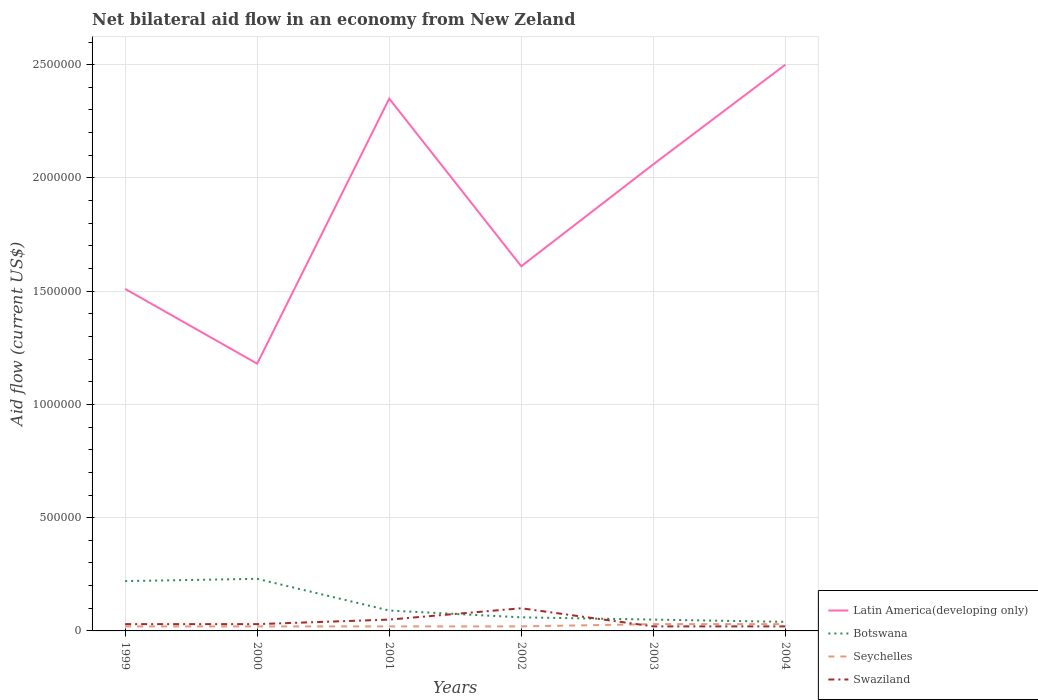Is the number of lines equal to the number of legend labels?
Offer a terse response. Yes. Across all years, what is the maximum net bilateral aid flow in Latin America(developing only)?
Ensure brevity in your answer.  1.18e+06. What is the difference between the highest and the second highest net bilateral aid flow in Botswana?
Give a very brief answer. 1.90e+05. What is the difference between the highest and the lowest net bilateral aid flow in Botswana?
Give a very brief answer. 2. How many lines are there?
Offer a terse response. 4. How many years are there in the graph?
Offer a terse response. 6. Are the values on the major ticks of Y-axis written in scientific E-notation?
Make the answer very short. No. Does the graph contain any zero values?
Give a very brief answer. No. Does the graph contain grids?
Your answer should be very brief. Yes. Where does the legend appear in the graph?
Provide a short and direct response. Bottom right. How are the legend labels stacked?
Give a very brief answer. Vertical. What is the title of the graph?
Offer a very short reply. Net bilateral aid flow in an economy from New Zeland. Does "Malaysia" appear as one of the legend labels in the graph?
Your answer should be very brief. No. What is the label or title of the Y-axis?
Keep it short and to the point. Aid flow (current US$). What is the Aid flow (current US$) of Latin America(developing only) in 1999?
Keep it short and to the point. 1.51e+06. What is the Aid flow (current US$) of Botswana in 1999?
Provide a short and direct response. 2.20e+05. What is the Aid flow (current US$) in Seychelles in 1999?
Your response must be concise. 2.00e+04. What is the Aid flow (current US$) of Swaziland in 1999?
Your answer should be compact. 3.00e+04. What is the Aid flow (current US$) of Latin America(developing only) in 2000?
Give a very brief answer. 1.18e+06. What is the Aid flow (current US$) in Latin America(developing only) in 2001?
Offer a very short reply. 2.35e+06. What is the Aid flow (current US$) in Botswana in 2001?
Ensure brevity in your answer.  9.00e+04. What is the Aid flow (current US$) in Seychelles in 2001?
Keep it short and to the point. 2.00e+04. What is the Aid flow (current US$) of Latin America(developing only) in 2002?
Your response must be concise. 1.61e+06. What is the Aid flow (current US$) of Latin America(developing only) in 2003?
Your response must be concise. 2.06e+06. What is the Aid flow (current US$) of Seychelles in 2003?
Ensure brevity in your answer.  3.00e+04. What is the Aid flow (current US$) of Swaziland in 2003?
Your response must be concise. 2.00e+04. What is the Aid flow (current US$) in Latin America(developing only) in 2004?
Keep it short and to the point. 2.50e+06. What is the Aid flow (current US$) in Botswana in 2004?
Offer a terse response. 4.00e+04. What is the Aid flow (current US$) in Seychelles in 2004?
Offer a very short reply. 3.00e+04. Across all years, what is the maximum Aid flow (current US$) in Latin America(developing only)?
Provide a succinct answer. 2.50e+06. Across all years, what is the minimum Aid flow (current US$) of Latin America(developing only)?
Keep it short and to the point. 1.18e+06. What is the total Aid flow (current US$) in Latin America(developing only) in the graph?
Provide a short and direct response. 1.12e+07. What is the total Aid flow (current US$) in Botswana in the graph?
Your answer should be compact. 6.90e+05. What is the difference between the Aid flow (current US$) of Latin America(developing only) in 1999 and that in 2000?
Provide a short and direct response. 3.30e+05. What is the difference between the Aid flow (current US$) in Botswana in 1999 and that in 2000?
Your response must be concise. -10000. What is the difference between the Aid flow (current US$) in Seychelles in 1999 and that in 2000?
Provide a succinct answer. 0. What is the difference between the Aid flow (current US$) of Swaziland in 1999 and that in 2000?
Your answer should be compact. 0. What is the difference between the Aid flow (current US$) in Latin America(developing only) in 1999 and that in 2001?
Provide a short and direct response. -8.40e+05. What is the difference between the Aid flow (current US$) in Botswana in 1999 and that in 2001?
Give a very brief answer. 1.30e+05. What is the difference between the Aid flow (current US$) of Seychelles in 1999 and that in 2001?
Offer a very short reply. 0. What is the difference between the Aid flow (current US$) in Swaziland in 1999 and that in 2001?
Give a very brief answer. -2.00e+04. What is the difference between the Aid flow (current US$) of Latin America(developing only) in 1999 and that in 2002?
Your response must be concise. -1.00e+05. What is the difference between the Aid flow (current US$) in Botswana in 1999 and that in 2002?
Offer a very short reply. 1.60e+05. What is the difference between the Aid flow (current US$) in Swaziland in 1999 and that in 2002?
Ensure brevity in your answer.  -7.00e+04. What is the difference between the Aid flow (current US$) in Latin America(developing only) in 1999 and that in 2003?
Your response must be concise. -5.50e+05. What is the difference between the Aid flow (current US$) in Botswana in 1999 and that in 2003?
Ensure brevity in your answer.  1.70e+05. What is the difference between the Aid flow (current US$) of Seychelles in 1999 and that in 2003?
Your response must be concise. -10000. What is the difference between the Aid flow (current US$) in Swaziland in 1999 and that in 2003?
Provide a short and direct response. 10000. What is the difference between the Aid flow (current US$) of Latin America(developing only) in 1999 and that in 2004?
Make the answer very short. -9.90e+05. What is the difference between the Aid flow (current US$) of Botswana in 1999 and that in 2004?
Offer a terse response. 1.80e+05. What is the difference between the Aid flow (current US$) of Seychelles in 1999 and that in 2004?
Your response must be concise. -10000. What is the difference between the Aid flow (current US$) of Latin America(developing only) in 2000 and that in 2001?
Your answer should be compact. -1.17e+06. What is the difference between the Aid flow (current US$) of Seychelles in 2000 and that in 2001?
Your answer should be compact. 0. What is the difference between the Aid flow (current US$) in Latin America(developing only) in 2000 and that in 2002?
Make the answer very short. -4.30e+05. What is the difference between the Aid flow (current US$) of Botswana in 2000 and that in 2002?
Offer a very short reply. 1.70e+05. What is the difference between the Aid flow (current US$) in Seychelles in 2000 and that in 2002?
Keep it short and to the point. 0. What is the difference between the Aid flow (current US$) in Swaziland in 2000 and that in 2002?
Make the answer very short. -7.00e+04. What is the difference between the Aid flow (current US$) of Latin America(developing only) in 2000 and that in 2003?
Your answer should be compact. -8.80e+05. What is the difference between the Aid flow (current US$) of Botswana in 2000 and that in 2003?
Your answer should be very brief. 1.80e+05. What is the difference between the Aid flow (current US$) in Seychelles in 2000 and that in 2003?
Give a very brief answer. -10000. What is the difference between the Aid flow (current US$) in Swaziland in 2000 and that in 2003?
Keep it short and to the point. 10000. What is the difference between the Aid flow (current US$) of Latin America(developing only) in 2000 and that in 2004?
Provide a short and direct response. -1.32e+06. What is the difference between the Aid flow (current US$) in Botswana in 2000 and that in 2004?
Offer a very short reply. 1.90e+05. What is the difference between the Aid flow (current US$) in Seychelles in 2000 and that in 2004?
Your response must be concise. -10000. What is the difference between the Aid flow (current US$) in Swaziland in 2000 and that in 2004?
Your answer should be very brief. 10000. What is the difference between the Aid flow (current US$) of Latin America(developing only) in 2001 and that in 2002?
Provide a succinct answer. 7.40e+05. What is the difference between the Aid flow (current US$) of Swaziland in 2001 and that in 2002?
Your answer should be very brief. -5.00e+04. What is the difference between the Aid flow (current US$) in Latin America(developing only) in 2001 and that in 2003?
Offer a very short reply. 2.90e+05. What is the difference between the Aid flow (current US$) of Botswana in 2001 and that in 2003?
Offer a very short reply. 4.00e+04. What is the difference between the Aid flow (current US$) in Swaziland in 2001 and that in 2003?
Provide a short and direct response. 3.00e+04. What is the difference between the Aid flow (current US$) in Botswana in 2001 and that in 2004?
Your response must be concise. 5.00e+04. What is the difference between the Aid flow (current US$) of Seychelles in 2001 and that in 2004?
Offer a terse response. -10000. What is the difference between the Aid flow (current US$) in Swaziland in 2001 and that in 2004?
Your answer should be compact. 3.00e+04. What is the difference between the Aid flow (current US$) in Latin America(developing only) in 2002 and that in 2003?
Your answer should be compact. -4.50e+05. What is the difference between the Aid flow (current US$) of Latin America(developing only) in 2002 and that in 2004?
Offer a terse response. -8.90e+05. What is the difference between the Aid flow (current US$) of Latin America(developing only) in 2003 and that in 2004?
Offer a very short reply. -4.40e+05. What is the difference between the Aid flow (current US$) in Seychelles in 2003 and that in 2004?
Offer a terse response. 0. What is the difference between the Aid flow (current US$) in Swaziland in 2003 and that in 2004?
Your answer should be compact. 0. What is the difference between the Aid flow (current US$) in Latin America(developing only) in 1999 and the Aid flow (current US$) in Botswana in 2000?
Make the answer very short. 1.28e+06. What is the difference between the Aid flow (current US$) of Latin America(developing only) in 1999 and the Aid flow (current US$) of Seychelles in 2000?
Your response must be concise. 1.49e+06. What is the difference between the Aid flow (current US$) in Latin America(developing only) in 1999 and the Aid flow (current US$) in Swaziland in 2000?
Keep it short and to the point. 1.48e+06. What is the difference between the Aid flow (current US$) in Botswana in 1999 and the Aid flow (current US$) in Seychelles in 2000?
Your answer should be compact. 2.00e+05. What is the difference between the Aid flow (current US$) of Seychelles in 1999 and the Aid flow (current US$) of Swaziland in 2000?
Offer a terse response. -10000. What is the difference between the Aid flow (current US$) of Latin America(developing only) in 1999 and the Aid flow (current US$) of Botswana in 2001?
Provide a short and direct response. 1.42e+06. What is the difference between the Aid flow (current US$) of Latin America(developing only) in 1999 and the Aid flow (current US$) of Seychelles in 2001?
Offer a very short reply. 1.49e+06. What is the difference between the Aid flow (current US$) in Latin America(developing only) in 1999 and the Aid flow (current US$) in Swaziland in 2001?
Give a very brief answer. 1.46e+06. What is the difference between the Aid flow (current US$) in Botswana in 1999 and the Aid flow (current US$) in Seychelles in 2001?
Provide a short and direct response. 2.00e+05. What is the difference between the Aid flow (current US$) in Botswana in 1999 and the Aid flow (current US$) in Swaziland in 2001?
Keep it short and to the point. 1.70e+05. What is the difference between the Aid flow (current US$) of Latin America(developing only) in 1999 and the Aid flow (current US$) of Botswana in 2002?
Provide a short and direct response. 1.45e+06. What is the difference between the Aid flow (current US$) of Latin America(developing only) in 1999 and the Aid flow (current US$) of Seychelles in 2002?
Offer a very short reply. 1.49e+06. What is the difference between the Aid flow (current US$) in Latin America(developing only) in 1999 and the Aid flow (current US$) in Swaziland in 2002?
Provide a short and direct response. 1.41e+06. What is the difference between the Aid flow (current US$) in Botswana in 1999 and the Aid flow (current US$) in Seychelles in 2002?
Your answer should be compact. 2.00e+05. What is the difference between the Aid flow (current US$) of Seychelles in 1999 and the Aid flow (current US$) of Swaziland in 2002?
Your response must be concise. -8.00e+04. What is the difference between the Aid flow (current US$) of Latin America(developing only) in 1999 and the Aid flow (current US$) of Botswana in 2003?
Your answer should be very brief. 1.46e+06. What is the difference between the Aid flow (current US$) of Latin America(developing only) in 1999 and the Aid flow (current US$) of Seychelles in 2003?
Give a very brief answer. 1.48e+06. What is the difference between the Aid flow (current US$) in Latin America(developing only) in 1999 and the Aid flow (current US$) in Swaziland in 2003?
Give a very brief answer. 1.49e+06. What is the difference between the Aid flow (current US$) of Botswana in 1999 and the Aid flow (current US$) of Seychelles in 2003?
Give a very brief answer. 1.90e+05. What is the difference between the Aid flow (current US$) in Latin America(developing only) in 1999 and the Aid flow (current US$) in Botswana in 2004?
Ensure brevity in your answer.  1.47e+06. What is the difference between the Aid flow (current US$) in Latin America(developing only) in 1999 and the Aid flow (current US$) in Seychelles in 2004?
Ensure brevity in your answer.  1.48e+06. What is the difference between the Aid flow (current US$) of Latin America(developing only) in 1999 and the Aid flow (current US$) of Swaziland in 2004?
Make the answer very short. 1.49e+06. What is the difference between the Aid flow (current US$) in Botswana in 1999 and the Aid flow (current US$) in Swaziland in 2004?
Your answer should be compact. 2.00e+05. What is the difference between the Aid flow (current US$) of Latin America(developing only) in 2000 and the Aid flow (current US$) of Botswana in 2001?
Your answer should be compact. 1.09e+06. What is the difference between the Aid flow (current US$) of Latin America(developing only) in 2000 and the Aid flow (current US$) of Seychelles in 2001?
Ensure brevity in your answer.  1.16e+06. What is the difference between the Aid flow (current US$) in Latin America(developing only) in 2000 and the Aid flow (current US$) in Swaziland in 2001?
Ensure brevity in your answer.  1.13e+06. What is the difference between the Aid flow (current US$) in Botswana in 2000 and the Aid flow (current US$) in Seychelles in 2001?
Offer a terse response. 2.10e+05. What is the difference between the Aid flow (current US$) in Botswana in 2000 and the Aid flow (current US$) in Swaziland in 2001?
Ensure brevity in your answer.  1.80e+05. What is the difference between the Aid flow (current US$) in Seychelles in 2000 and the Aid flow (current US$) in Swaziland in 2001?
Your answer should be compact. -3.00e+04. What is the difference between the Aid flow (current US$) in Latin America(developing only) in 2000 and the Aid flow (current US$) in Botswana in 2002?
Your response must be concise. 1.12e+06. What is the difference between the Aid flow (current US$) in Latin America(developing only) in 2000 and the Aid flow (current US$) in Seychelles in 2002?
Ensure brevity in your answer.  1.16e+06. What is the difference between the Aid flow (current US$) of Latin America(developing only) in 2000 and the Aid flow (current US$) of Swaziland in 2002?
Your answer should be very brief. 1.08e+06. What is the difference between the Aid flow (current US$) of Botswana in 2000 and the Aid flow (current US$) of Seychelles in 2002?
Your response must be concise. 2.10e+05. What is the difference between the Aid flow (current US$) of Botswana in 2000 and the Aid flow (current US$) of Swaziland in 2002?
Give a very brief answer. 1.30e+05. What is the difference between the Aid flow (current US$) of Seychelles in 2000 and the Aid flow (current US$) of Swaziland in 2002?
Make the answer very short. -8.00e+04. What is the difference between the Aid flow (current US$) in Latin America(developing only) in 2000 and the Aid flow (current US$) in Botswana in 2003?
Provide a succinct answer. 1.13e+06. What is the difference between the Aid flow (current US$) of Latin America(developing only) in 2000 and the Aid flow (current US$) of Seychelles in 2003?
Provide a short and direct response. 1.15e+06. What is the difference between the Aid flow (current US$) of Latin America(developing only) in 2000 and the Aid flow (current US$) of Swaziland in 2003?
Provide a short and direct response. 1.16e+06. What is the difference between the Aid flow (current US$) of Botswana in 2000 and the Aid flow (current US$) of Seychelles in 2003?
Your response must be concise. 2.00e+05. What is the difference between the Aid flow (current US$) of Seychelles in 2000 and the Aid flow (current US$) of Swaziland in 2003?
Offer a terse response. 0. What is the difference between the Aid flow (current US$) in Latin America(developing only) in 2000 and the Aid flow (current US$) in Botswana in 2004?
Make the answer very short. 1.14e+06. What is the difference between the Aid flow (current US$) in Latin America(developing only) in 2000 and the Aid flow (current US$) in Seychelles in 2004?
Your response must be concise. 1.15e+06. What is the difference between the Aid flow (current US$) in Latin America(developing only) in 2000 and the Aid flow (current US$) in Swaziland in 2004?
Keep it short and to the point. 1.16e+06. What is the difference between the Aid flow (current US$) of Botswana in 2000 and the Aid flow (current US$) of Swaziland in 2004?
Offer a terse response. 2.10e+05. What is the difference between the Aid flow (current US$) of Latin America(developing only) in 2001 and the Aid flow (current US$) of Botswana in 2002?
Provide a succinct answer. 2.29e+06. What is the difference between the Aid flow (current US$) in Latin America(developing only) in 2001 and the Aid flow (current US$) in Seychelles in 2002?
Your answer should be very brief. 2.33e+06. What is the difference between the Aid flow (current US$) of Latin America(developing only) in 2001 and the Aid flow (current US$) of Swaziland in 2002?
Provide a short and direct response. 2.25e+06. What is the difference between the Aid flow (current US$) of Botswana in 2001 and the Aid flow (current US$) of Seychelles in 2002?
Offer a very short reply. 7.00e+04. What is the difference between the Aid flow (current US$) in Latin America(developing only) in 2001 and the Aid flow (current US$) in Botswana in 2003?
Give a very brief answer. 2.30e+06. What is the difference between the Aid flow (current US$) in Latin America(developing only) in 2001 and the Aid flow (current US$) in Seychelles in 2003?
Your answer should be very brief. 2.32e+06. What is the difference between the Aid flow (current US$) in Latin America(developing only) in 2001 and the Aid flow (current US$) in Swaziland in 2003?
Offer a terse response. 2.33e+06. What is the difference between the Aid flow (current US$) of Botswana in 2001 and the Aid flow (current US$) of Seychelles in 2003?
Offer a very short reply. 6.00e+04. What is the difference between the Aid flow (current US$) in Botswana in 2001 and the Aid flow (current US$) in Swaziland in 2003?
Your answer should be compact. 7.00e+04. What is the difference between the Aid flow (current US$) of Latin America(developing only) in 2001 and the Aid flow (current US$) of Botswana in 2004?
Offer a terse response. 2.31e+06. What is the difference between the Aid flow (current US$) of Latin America(developing only) in 2001 and the Aid flow (current US$) of Seychelles in 2004?
Your answer should be compact. 2.32e+06. What is the difference between the Aid flow (current US$) of Latin America(developing only) in 2001 and the Aid flow (current US$) of Swaziland in 2004?
Your answer should be compact. 2.33e+06. What is the difference between the Aid flow (current US$) in Botswana in 2001 and the Aid flow (current US$) in Swaziland in 2004?
Ensure brevity in your answer.  7.00e+04. What is the difference between the Aid flow (current US$) in Latin America(developing only) in 2002 and the Aid flow (current US$) in Botswana in 2003?
Make the answer very short. 1.56e+06. What is the difference between the Aid flow (current US$) in Latin America(developing only) in 2002 and the Aid flow (current US$) in Seychelles in 2003?
Keep it short and to the point. 1.58e+06. What is the difference between the Aid flow (current US$) of Latin America(developing only) in 2002 and the Aid flow (current US$) of Swaziland in 2003?
Make the answer very short. 1.59e+06. What is the difference between the Aid flow (current US$) of Botswana in 2002 and the Aid flow (current US$) of Swaziland in 2003?
Ensure brevity in your answer.  4.00e+04. What is the difference between the Aid flow (current US$) in Latin America(developing only) in 2002 and the Aid flow (current US$) in Botswana in 2004?
Offer a very short reply. 1.57e+06. What is the difference between the Aid flow (current US$) in Latin America(developing only) in 2002 and the Aid flow (current US$) in Seychelles in 2004?
Provide a succinct answer. 1.58e+06. What is the difference between the Aid flow (current US$) in Latin America(developing only) in 2002 and the Aid flow (current US$) in Swaziland in 2004?
Offer a very short reply. 1.59e+06. What is the difference between the Aid flow (current US$) of Botswana in 2002 and the Aid flow (current US$) of Seychelles in 2004?
Offer a terse response. 3.00e+04. What is the difference between the Aid flow (current US$) of Botswana in 2002 and the Aid flow (current US$) of Swaziland in 2004?
Your answer should be compact. 4.00e+04. What is the difference between the Aid flow (current US$) of Seychelles in 2002 and the Aid flow (current US$) of Swaziland in 2004?
Ensure brevity in your answer.  0. What is the difference between the Aid flow (current US$) of Latin America(developing only) in 2003 and the Aid flow (current US$) of Botswana in 2004?
Your answer should be compact. 2.02e+06. What is the difference between the Aid flow (current US$) in Latin America(developing only) in 2003 and the Aid flow (current US$) in Seychelles in 2004?
Ensure brevity in your answer.  2.03e+06. What is the difference between the Aid flow (current US$) in Latin America(developing only) in 2003 and the Aid flow (current US$) in Swaziland in 2004?
Keep it short and to the point. 2.04e+06. What is the difference between the Aid flow (current US$) in Botswana in 2003 and the Aid flow (current US$) in Seychelles in 2004?
Your answer should be very brief. 2.00e+04. What is the difference between the Aid flow (current US$) in Botswana in 2003 and the Aid flow (current US$) in Swaziland in 2004?
Provide a short and direct response. 3.00e+04. What is the difference between the Aid flow (current US$) of Seychelles in 2003 and the Aid flow (current US$) of Swaziland in 2004?
Ensure brevity in your answer.  10000. What is the average Aid flow (current US$) of Latin America(developing only) per year?
Your response must be concise. 1.87e+06. What is the average Aid flow (current US$) of Botswana per year?
Provide a succinct answer. 1.15e+05. What is the average Aid flow (current US$) of Seychelles per year?
Your response must be concise. 2.33e+04. What is the average Aid flow (current US$) of Swaziland per year?
Ensure brevity in your answer.  4.17e+04. In the year 1999, what is the difference between the Aid flow (current US$) of Latin America(developing only) and Aid flow (current US$) of Botswana?
Ensure brevity in your answer.  1.29e+06. In the year 1999, what is the difference between the Aid flow (current US$) in Latin America(developing only) and Aid flow (current US$) in Seychelles?
Keep it short and to the point. 1.49e+06. In the year 1999, what is the difference between the Aid flow (current US$) in Latin America(developing only) and Aid flow (current US$) in Swaziland?
Provide a succinct answer. 1.48e+06. In the year 1999, what is the difference between the Aid flow (current US$) in Botswana and Aid flow (current US$) in Seychelles?
Your answer should be very brief. 2.00e+05. In the year 2000, what is the difference between the Aid flow (current US$) in Latin America(developing only) and Aid flow (current US$) in Botswana?
Your response must be concise. 9.50e+05. In the year 2000, what is the difference between the Aid flow (current US$) of Latin America(developing only) and Aid flow (current US$) of Seychelles?
Ensure brevity in your answer.  1.16e+06. In the year 2000, what is the difference between the Aid flow (current US$) in Latin America(developing only) and Aid flow (current US$) in Swaziland?
Offer a very short reply. 1.15e+06. In the year 2000, what is the difference between the Aid flow (current US$) in Botswana and Aid flow (current US$) in Swaziland?
Provide a short and direct response. 2.00e+05. In the year 2001, what is the difference between the Aid flow (current US$) in Latin America(developing only) and Aid flow (current US$) in Botswana?
Offer a terse response. 2.26e+06. In the year 2001, what is the difference between the Aid flow (current US$) in Latin America(developing only) and Aid flow (current US$) in Seychelles?
Offer a terse response. 2.33e+06. In the year 2001, what is the difference between the Aid flow (current US$) in Latin America(developing only) and Aid flow (current US$) in Swaziland?
Your answer should be compact. 2.30e+06. In the year 2001, what is the difference between the Aid flow (current US$) in Botswana and Aid flow (current US$) in Swaziland?
Offer a terse response. 4.00e+04. In the year 2001, what is the difference between the Aid flow (current US$) in Seychelles and Aid flow (current US$) in Swaziland?
Give a very brief answer. -3.00e+04. In the year 2002, what is the difference between the Aid flow (current US$) of Latin America(developing only) and Aid flow (current US$) of Botswana?
Offer a terse response. 1.55e+06. In the year 2002, what is the difference between the Aid flow (current US$) of Latin America(developing only) and Aid flow (current US$) of Seychelles?
Offer a terse response. 1.59e+06. In the year 2002, what is the difference between the Aid flow (current US$) of Latin America(developing only) and Aid flow (current US$) of Swaziland?
Provide a succinct answer. 1.51e+06. In the year 2002, what is the difference between the Aid flow (current US$) in Botswana and Aid flow (current US$) in Seychelles?
Your response must be concise. 4.00e+04. In the year 2002, what is the difference between the Aid flow (current US$) in Seychelles and Aid flow (current US$) in Swaziland?
Make the answer very short. -8.00e+04. In the year 2003, what is the difference between the Aid flow (current US$) of Latin America(developing only) and Aid flow (current US$) of Botswana?
Keep it short and to the point. 2.01e+06. In the year 2003, what is the difference between the Aid flow (current US$) in Latin America(developing only) and Aid flow (current US$) in Seychelles?
Offer a terse response. 2.03e+06. In the year 2003, what is the difference between the Aid flow (current US$) in Latin America(developing only) and Aid flow (current US$) in Swaziland?
Offer a terse response. 2.04e+06. In the year 2004, what is the difference between the Aid flow (current US$) of Latin America(developing only) and Aid flow (current US$) of Botswana?
Provide a short and direct response. 2.46e+06. In the year 2004, what is the difference between the Aid flow (current US$) of Latin America(developing only) and Aid flow (current US$) of Seychelles?
Give a very brief answer. 2.47e+06. In the year 2004, what is the difference between the Aid flow (current US$) in Latin America(developing only) and Aid flow (current US$) in Swaziland?
Your answer should be compact. 2.48e+06. What is the ratio of the Aid flow (current US$) of Latin America(developing only) in 1999 to that in 2000?
Keep it short and to the point. 1.28. What is the ratio of the Aid flow (current US$) in Botswana in 1999 to that in 2000?
Your answer should be compact. 0.96. What is the ratio of the Aid flow (current US$) of Seychelles in 1999 to that in 2000?
Your answer should be very brief. 1. What is the ratio of the Aid flow (current US$) of Latin America(developing only) in 1999 to that in 2001?
Your response must be concise. 0.64. What is the ratio of the Aid flow (current US$) in Botswana in 1999 to that in 2001?
Give a very brief answer. 2.44. What is the ratio of the Aid flow (current US$) of Swaziland in 1999 to that in 2001?
Offer a terse response. 0.6. What is the ratio of the Aid flow (current US$) of Latin America(developing only) in 1999 to that in 2002?
Your response must be concise. 0.94. What is the ratio of the Aid flow (current US$) of Botswana in 1999 to that in 2002?
Provide a short and direct response. 3.67. What is the ratio of the Aid flow (current US$) in Latin America(developing only) in 1999 to that in 2003?
Your answer should be compact. 0.73. What is the ratio of the Aid flow (current US$) in Latin America(developing only) in 1999 to that in 2004?
Provide a short and direct response. 0.6. What is the ratio of the Aid flow (current US$) of Seychelles in 1999 to that in 2004?
Keep it short and to the point. 0.67. What is the ratio of the Aid flow (current US$) in Latin America(developing only) in 2000 to that in 2001?
Make the answer very short. 0.5. What is the ratio of the Aid flow (current US$) in Botswana in 2000 to that in 2001?
Provide a succinct answer. 2.56. What is the ratio of the Aid flow (current US$) of Latin America(developing only) in 2000 to that in 2002?
Your answer should be compact. 0.73. What is the ratio of the Aid flow (current US$) in Botswana in 2000 to that in 2002?
Provide a succinct answer. 3.83. What is the ratio of the Aid flow (current US$) in Seychelles in 2000 to that in 2002?
Ensure brevity in your answer.  1. What is the ratio of the Aid flow (current US$) of Latin America(developing only) in 2000 to that in 2003?
Keep it short and to the point. 0.57. What is the ratio of the Aid flow (current US$) of Latin America(developing only) in 2000 to that in 2004?
Provide a short and direct response. 0.47. What is the ratio of the Aid flow (current US$) in Botswana in 2000 to that in 2004?
Offer a terse response. 5.75. What is the ratio of the Aid flow (current US$) in Swaziland in 2000 to that in 2004?
Make the answer very short. 1.5. What is the ratio of the Aid flow (current US$) in Latin America(developing only) in 2001 to that in 2002?
Offer a terse response. 1.46. What is the ratio of the Aid flow (current US$) in Botswana in 2001 to that in 2002?
Your response must be concise. 1.5. What is the ratio of the Aid flow (current US$) of Seychelles in 2001 to that in 2002?
Keep it short and to the point. 1. What is the ratio of the Aid flow (current US$) in Latin America(developing only) in 2001 to that in 2003?
Ensure brevity in your answer.  1.14. What is the ratio of the Aid flow (current US$) of Botswana in 2001 to that in 2003?
Your response must be concise. 1.8. What is the ratio of the Aid flow (current US$) of Seychelles in 2001 to that in 2003?
Ensure brevity in your answer.  0.67. What is the ratio of the Aid flow (current US$) of Swaziland in 2001 to that in 2003?
Ensure brevity in your answer.  2.5. What is the ratio of the Aid flow (current US$) of Latin America(developing only) in 2001 to that in 2004?
Ensure brevity in your answer.  0.94. What is the ratio of the Aid flow (current US$) of Botswana in 2001 to that in 2004?
Your answer should be very brief. 2.25. What is the ratio of the Aid flow (current US$) in Seychelles in 2001 to that in 2004?
Your answer should be very brief. 0.67. What is the ratio of the Aid flow (current US$) of Swaziland in 2001 to that in 2004?
Provide a short and direct response. 2.5. What is the ratio of the Aid flow (current US$) of Latin America(developing only) in 2002 to that in 2003?
Keep it short and to the point. 0.78. What is the ratio of the Aid flow (current US$) in Botswana in 2002 to that in 2003?
Ensure brevity in your answer.  1.2. What is the ratio of the Aid flow (current US$) of Latin America(developing only) in 2002 to that in 2004?
Your response must be concise. 0.64. What is the ratio of the Aid flow (current US$) in Botswana in 2002 to that in 2004?
Keep it short and to the point. 1.5. What is the ratio of the Aid flow (current US$) of Latin America(developing only) in 2003 to that in 2004?
Your answer should be compact. 0.82. What is the difference between the highest and the second highest Aid flow (current US$) in Botswana?
Your answer should be very brief. 10000. What is the difference between the highest and the lowest Aid flow (current US$) of Latin America(developing only)?
Provide a short and direct response. 1.32e+06. What is the difference between the highest and the lowest Aid flow (current US$) of Botswana?
Your response must be concise. 1.90e+05. What is the difference between the highest and the lowest Aid flow (current US$) of Seychelles?
Make the answer very short. 10000. What is the difference between the highest and the lowest Aid flow (current US$) in Swaziland?
Offer a very short reply. 8.00e+04. 